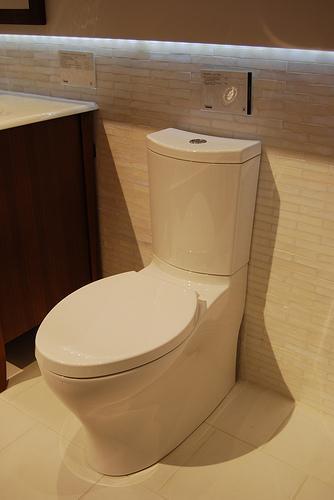How many toilets are in the picture?
Give a very brief answer. 1. 